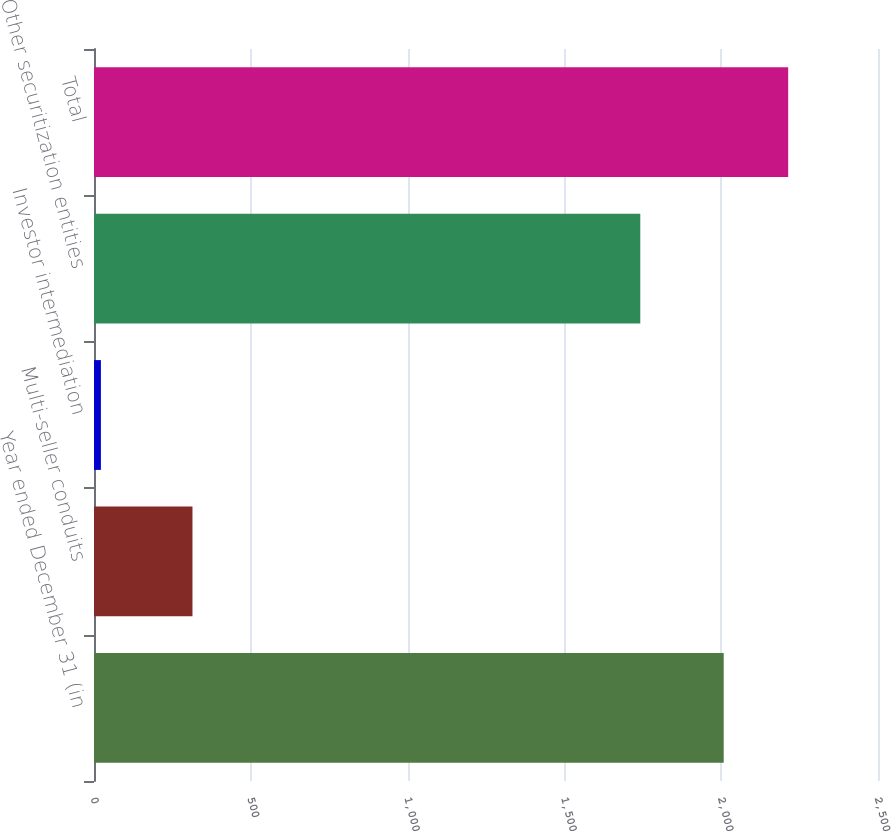<chart> <loc_0><loc_0><loc_500><loc_500><bar_chart><fcel>Year ended December 31 (in<fcel>Multi-seller conduits<fcel>Investor intermediation<fcel>Other securitization entities<fcel>Total<nl><fcel>2008<fcel>314<fcel>22<fcel>1742<fcel>2213.6<nl></chart> 